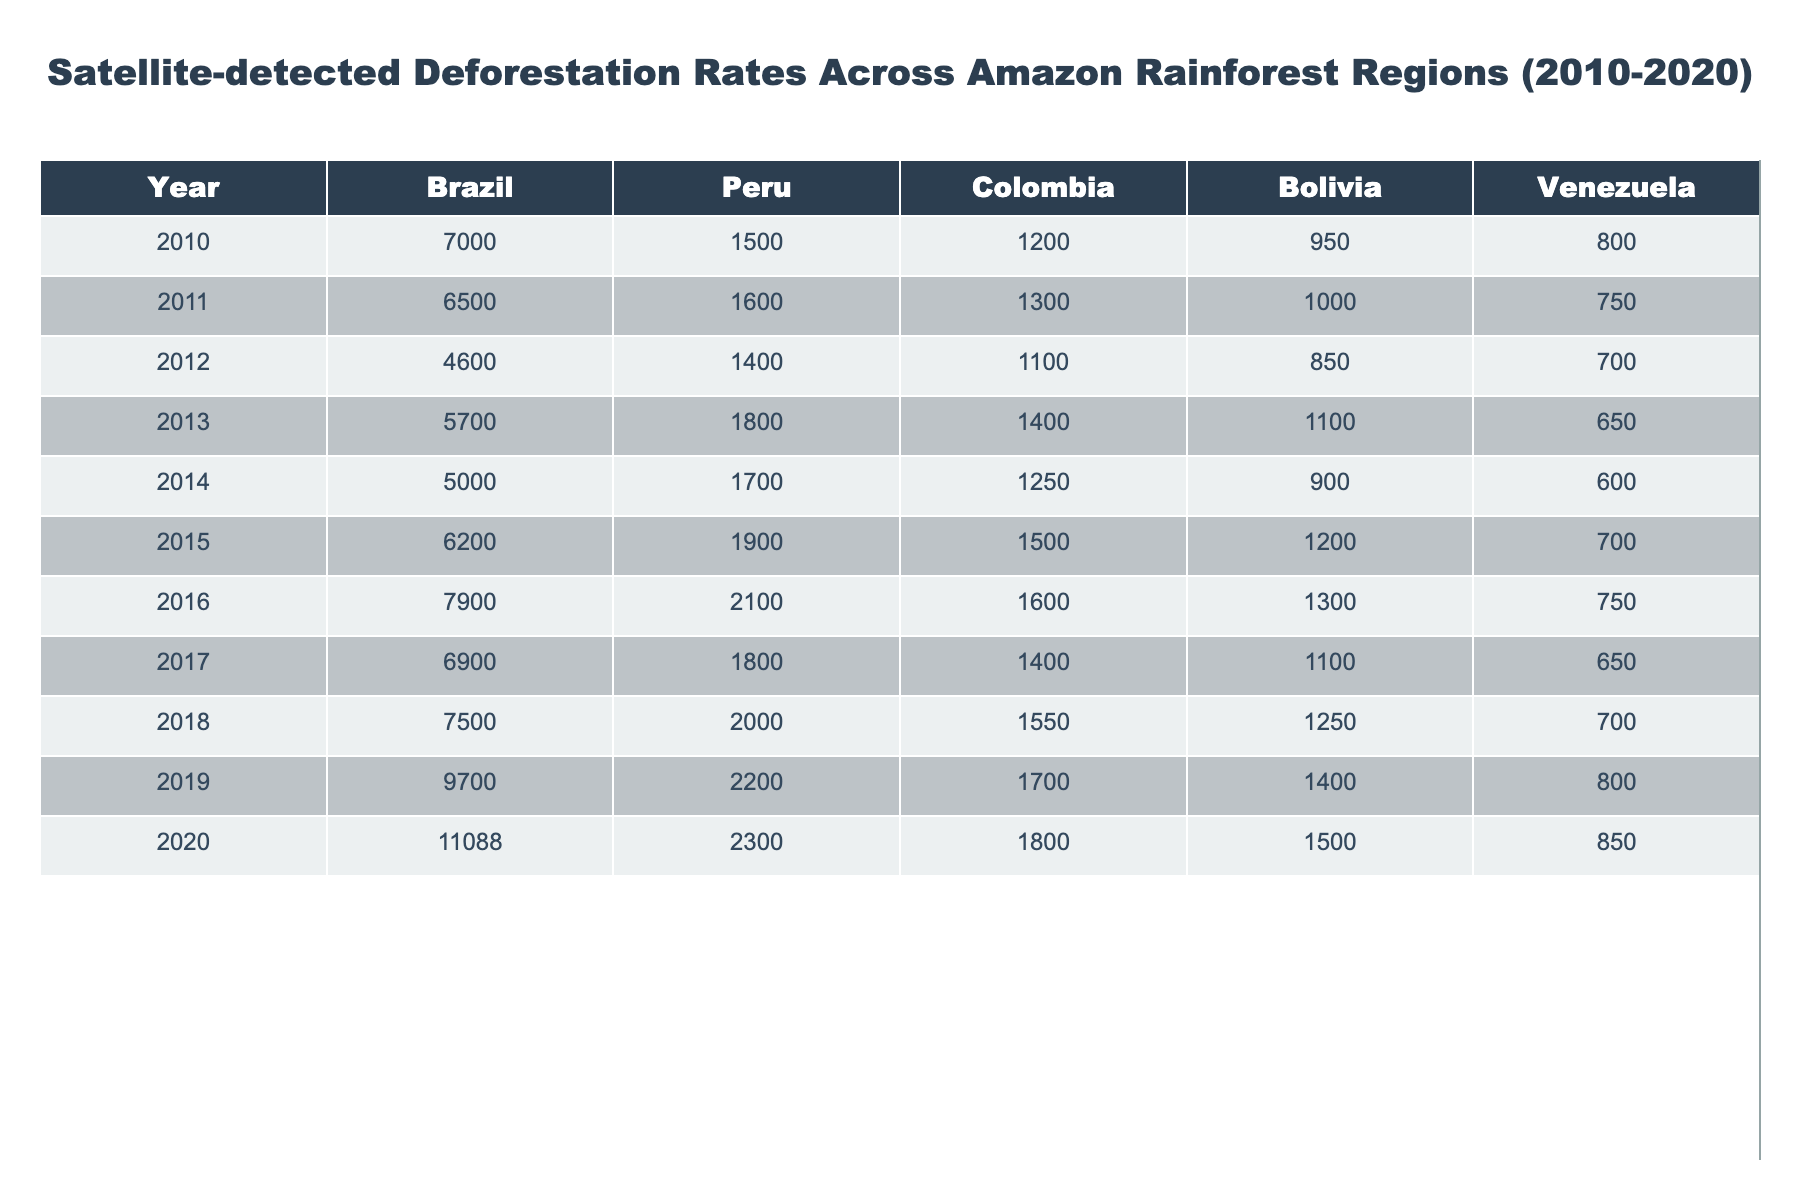What was the deforestation rate in Brazil in 2016? The table shows that in 2016, the deforestation rate for Brazil was listed as 7900.
Answer: 7900 Which country had the highest deforestation rate in 2020? Looking at the values for the year 2020, Brazil has the highest deforestation rate at 11088.
Answer: Brazil What is the average deforestation rate for Peru over the years 2010 to 2020? We can calculate the average by summing the deforestation rates for Peru from 2010 to 2020: (1500 + 1600 + 1400 + 1800 + 1700 + 1900 + 2000 + 2200 + 2300) = 14500. Dividing by 9 gives us an average of 14500/9 ≈ 1611.11.
Answer: Approximately 1611.11 Did Colombia experience an increase in deforestation from 2010 to 2020? By comparing the values for Colombia in 2010 (1200) and 2020 (1800), we see that it increased from 1200 to 1800, confirming an increase.
Answer: Yes What was the total deforestation rate across all countries in 2019? We sum the deforestation rates for 2019: (9700 + 2200 + 1700 + 1400 + 800) = 13800.
Answer: 13800 Which country had the lowest deforestation rate in 2015? The table shows that in 2015 the lowest deforestation rate was in Venezuela, with a rate of 700.
Answer: Venezuela What is the difference in deforestation rates between Bolivia in 2013 and 2018? In 2013, Bolivia's deforestation rate was 1100, and in 2018, it was 1250. The difference is 1250 - 1100 = 150.
Answer: 150 Based on the table, which country showed consistent growth in deforestation rates from 2010 to 2020? Examining the values year by year, Brazil shows an overall increasing trend from 7000 in 2010 to 11088 in 2020.
Answer: Brazil What was the total deforestation rate for Venezuela over the years? Adding up the values for Venezuela: (800 + 750 + 700 + 650 + 600 + 700 + 750 + 700 + 850) = 5550.
Answer: 5550 In which year did Colombia have the lowest deforestation rate? By reviewing the table, we see that in 2012, Colombia had the lowest deforestation rate at 1100.
Answer: 2012 